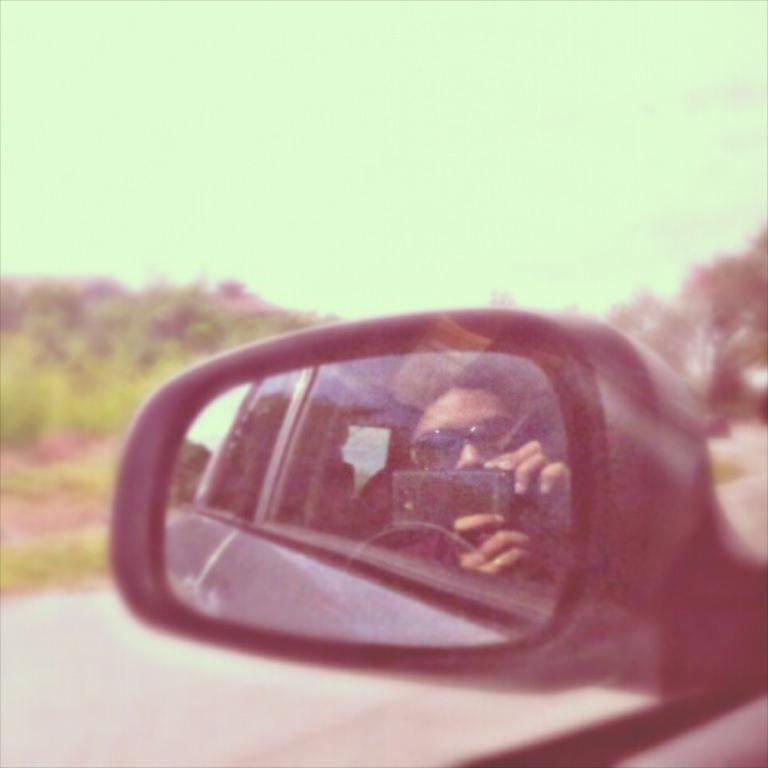Can you describe this image briefly? This picture shows a side mirror of a vehicle and in the mirror, we see a woman holding a mobile and she wore sunglasses on her face and we see trees. 